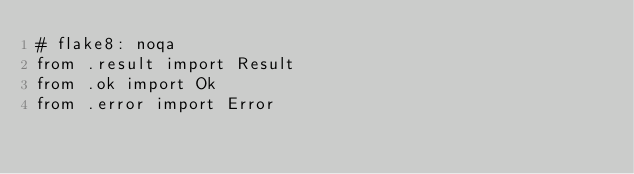<code> <loc_0><loc_0><loc_500><loc_500><_Python_># flake8: noqa
from .result import Result
from .ok import Ok
from .error import Error
</code> 